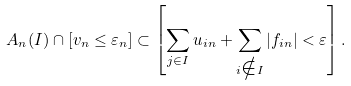Convert formula to latex. <formula><loc_0><loc_0><loc_500><loc_500>A _ { n } ( I ) \cap [ v _ { n } \leq \varepsilon _ { n } ] \subset \left [ \sum _ { j \in I } u _ { i n } + \sum _ { i \notin I } | f _ { i n } | < \varepsilon \right ] .</formula> 